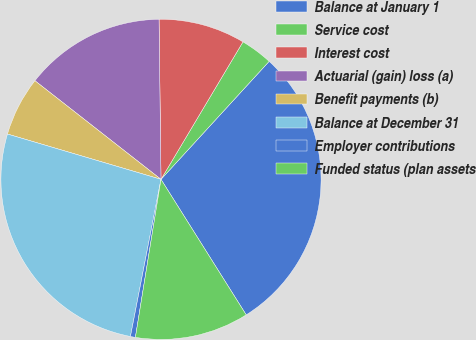Convert chart to OTSL. <chart><loc_0><loc_0><loc_500><loc_500><pie_chart><fcel>Balance at January 1<fcel>Service cost<fcel>Interest cost<fcel>Actuarial (gain) loss (a)<fcel>Benefit payments (b)<fcel>Balance at December 31<fcel>Employer contributions<fcel>Funded status (plan assets<nl><fcel>29.26%<fcel>3.25%<fcel>8.75%<fcel>14.24%<fcel>6.0%<fcel>26.51%<fcel>0.5%<fcel>11.49%<nl></chart> 